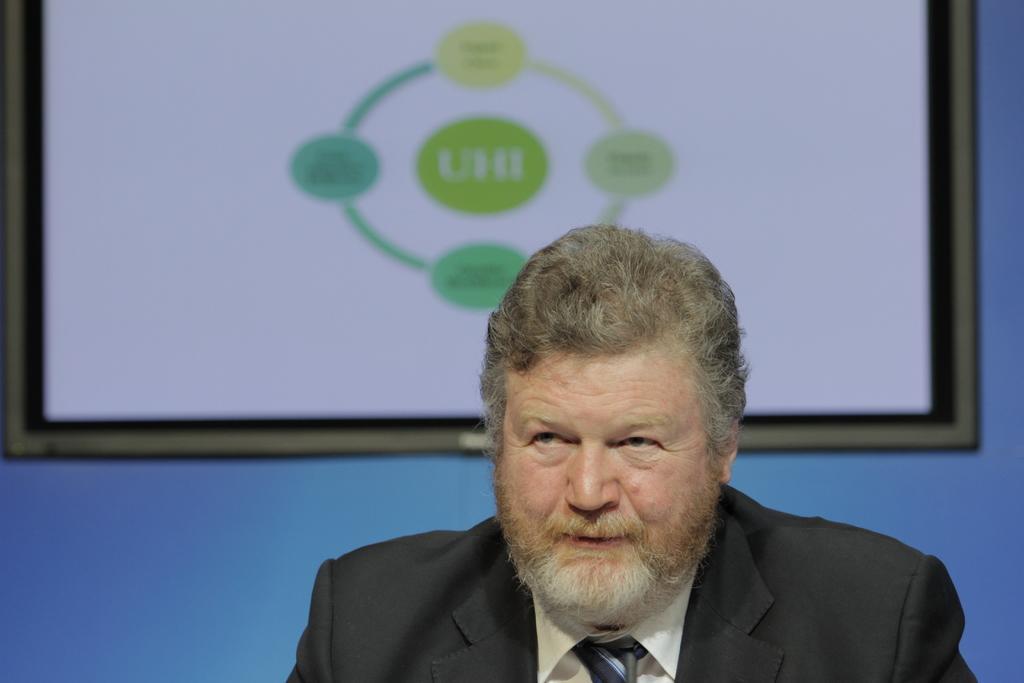Can you describe this image briefly? Here I can see a man wearing a suit. It seems like he is speaking. In the background there is a frame. The background is in blue color. 